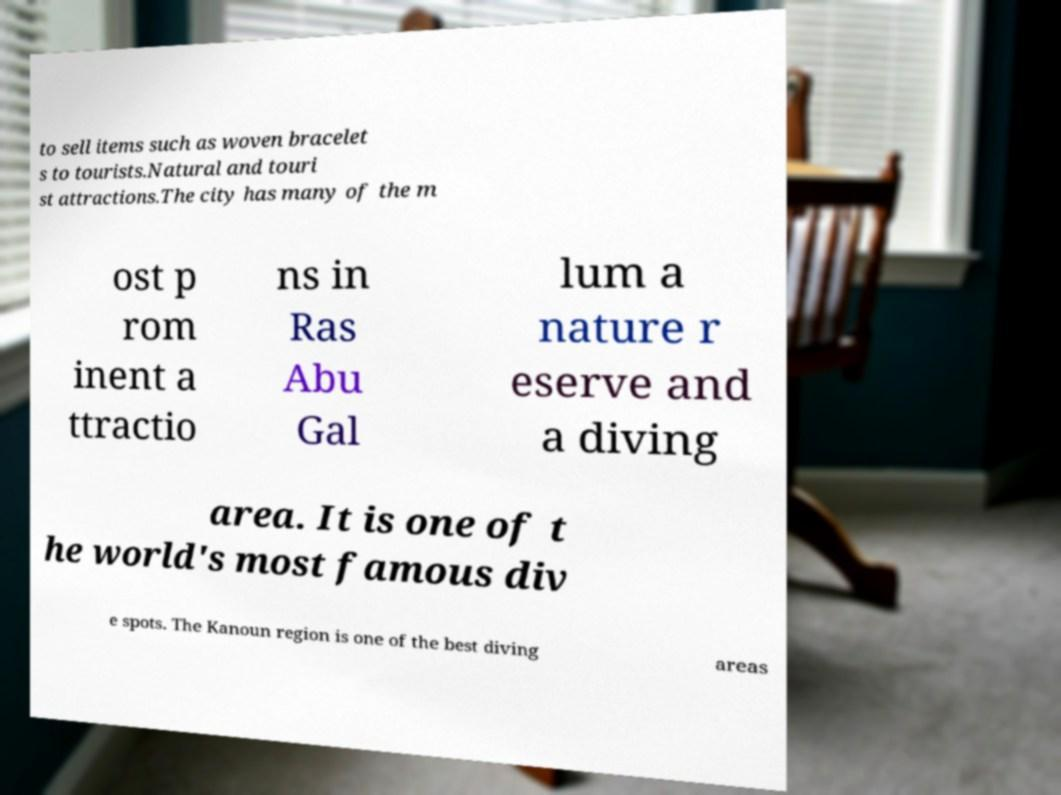I need the written content from this picture converted into text. Can you do that? to sell items such as woven bracelet s to tourists.Natural and touri st attractions.The city has many of the m ost p rom inent a ttractio ns in Ras Abu Gal lum a nature r eserve and a diving area. It is one of t he world's most famous div e spots. The Kanoun region is one of the best diving areas 